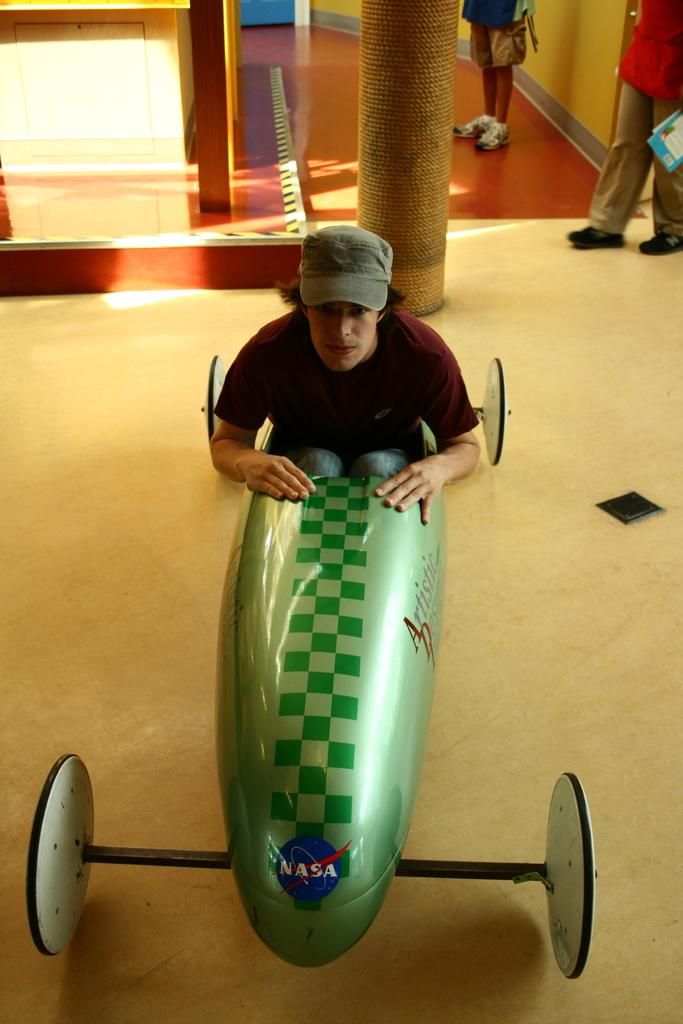<image>
Write a terse but informative summary of the picture. A boy sits in a green vehicle with NASA at the front. 